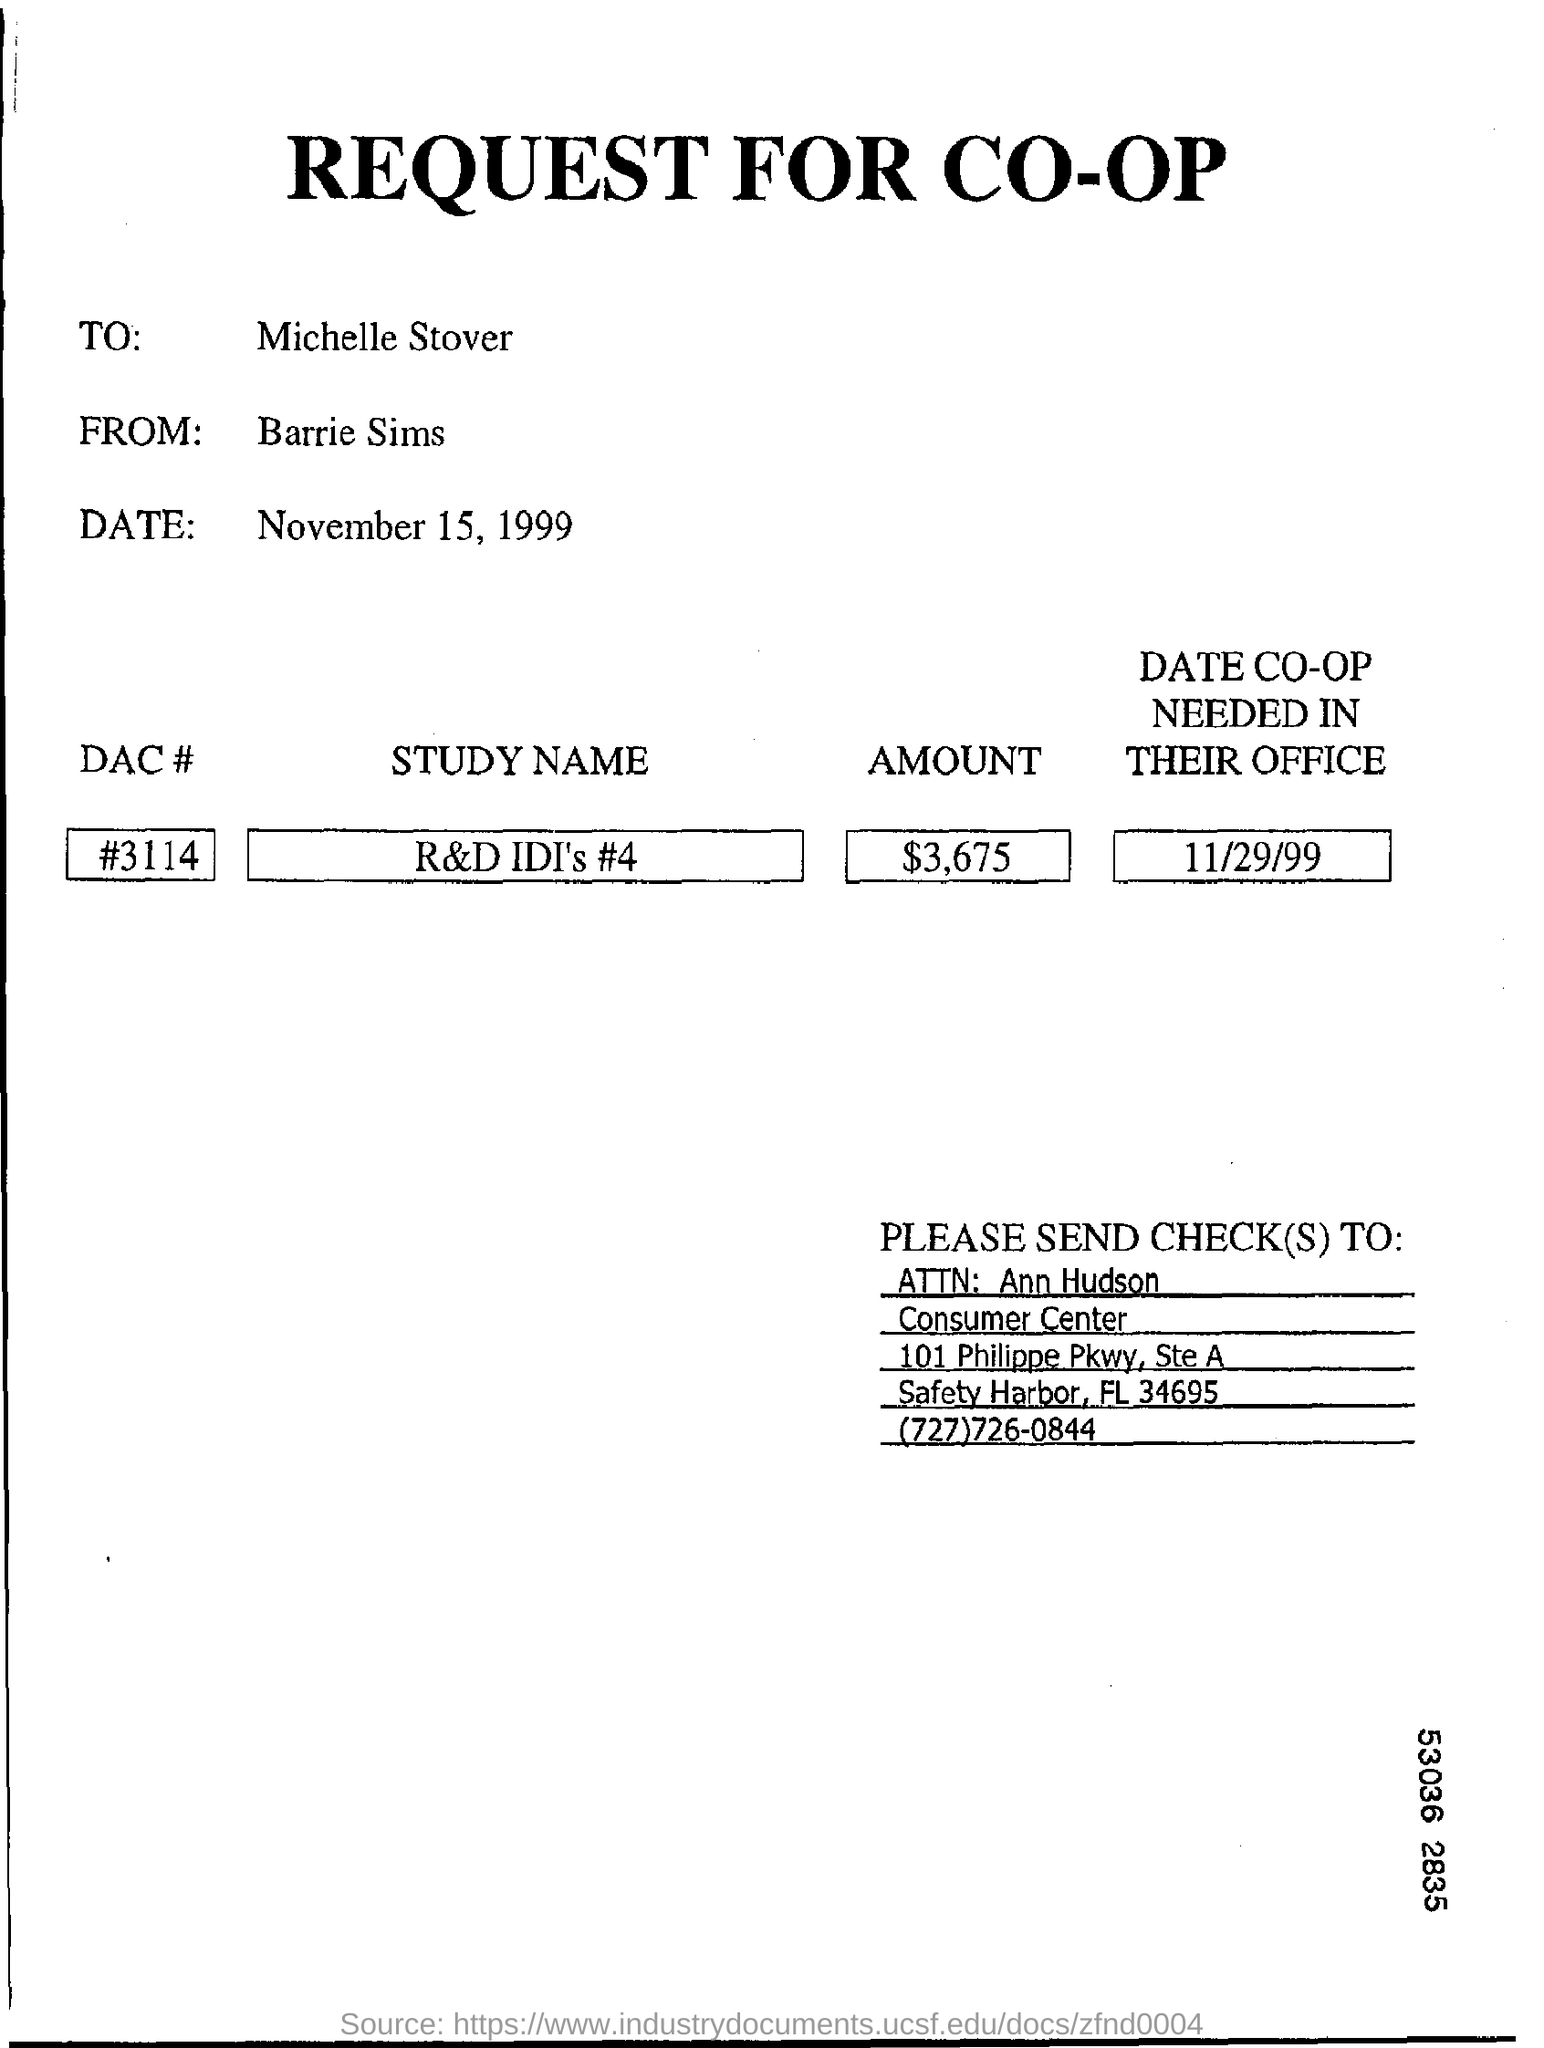Outline some significant characteristics in this image. What is the DAC number? It is 3114. Barrie Sims sends the request. The date that is needed in the office is 11/29/99. 